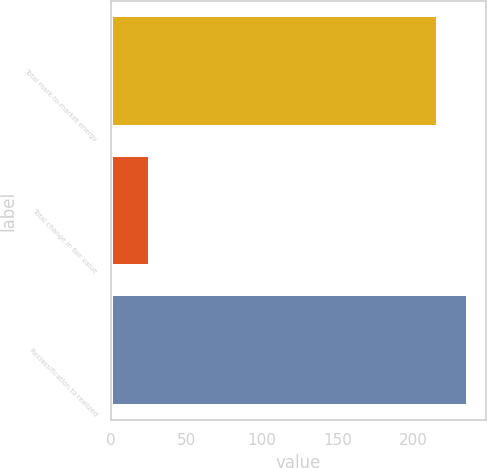<chart> <loc_0><loc_0><loc_500><loc_500><bar_chart><fcel>Total mark-to-market energy<fcel>Total change in fair value<fcel>Reclassification to realized<nl><fcel>217<fcel>26<fcel>236.7<nl></chart> 